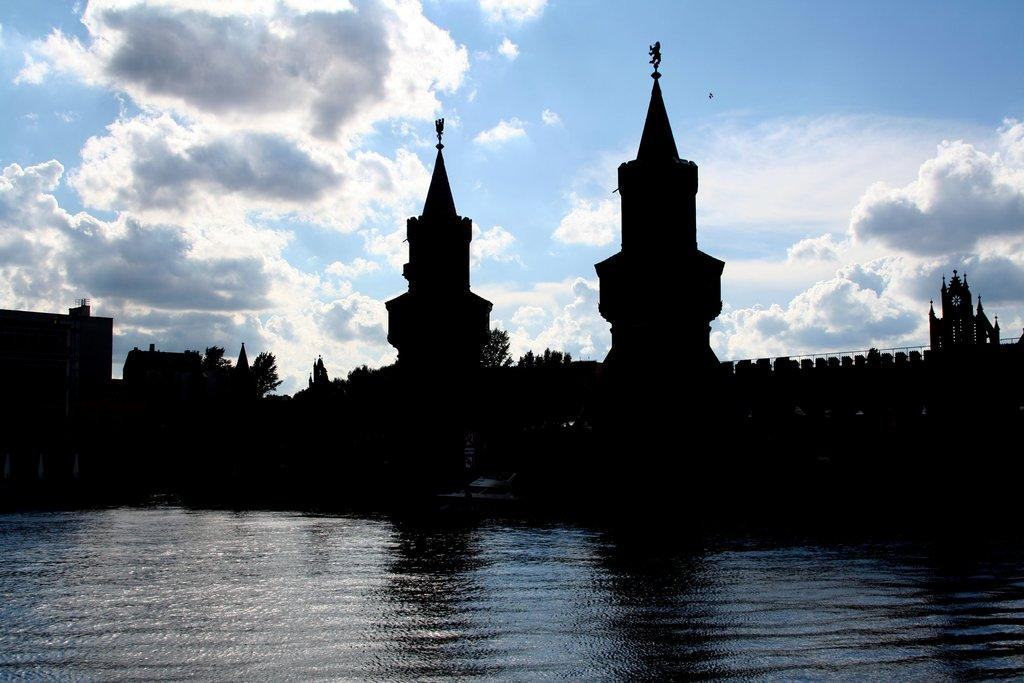What is the main feature of the image? There is water in the image. What is floating on the water? There is a boat in the image. What structures can be seen in the image? There are towers in the image. What type of vegetation is present in the image? There are trees in the image. What is visible above the water and the structures? The sky is visible in the image. How would you describe the weather based on the sky? The sky is cloudy in the image. What type of metal is used to build the oven in the image? There is no oven present in the image; it features water, a boat, towers, trees, and a cloudy sky. 